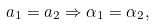Convert formula to latex. <formula><loc_0><loc_0><loc_500><loc_500>a _ { 1 } = a _ { 2 } \Rightarrow \alpha _ { 1 } = \alpha _ { 2 } ,</formula> 